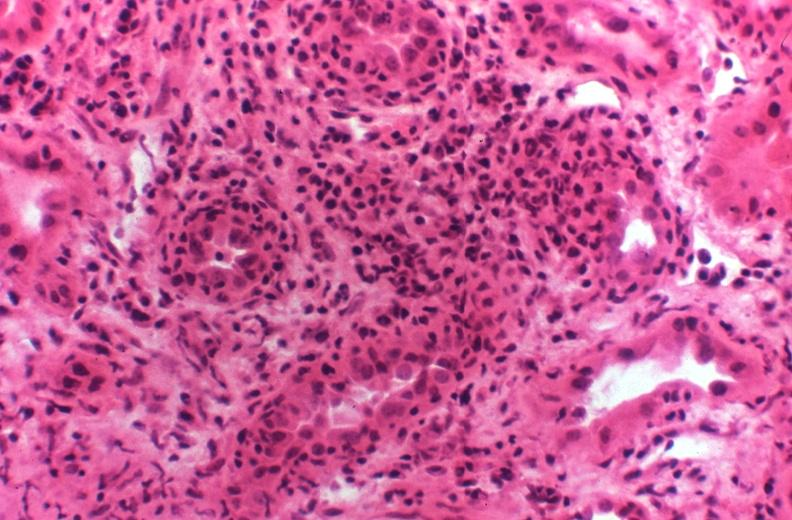does this image show kidney transplant rejection?
Answer the question using a single word or phrase. Yes 